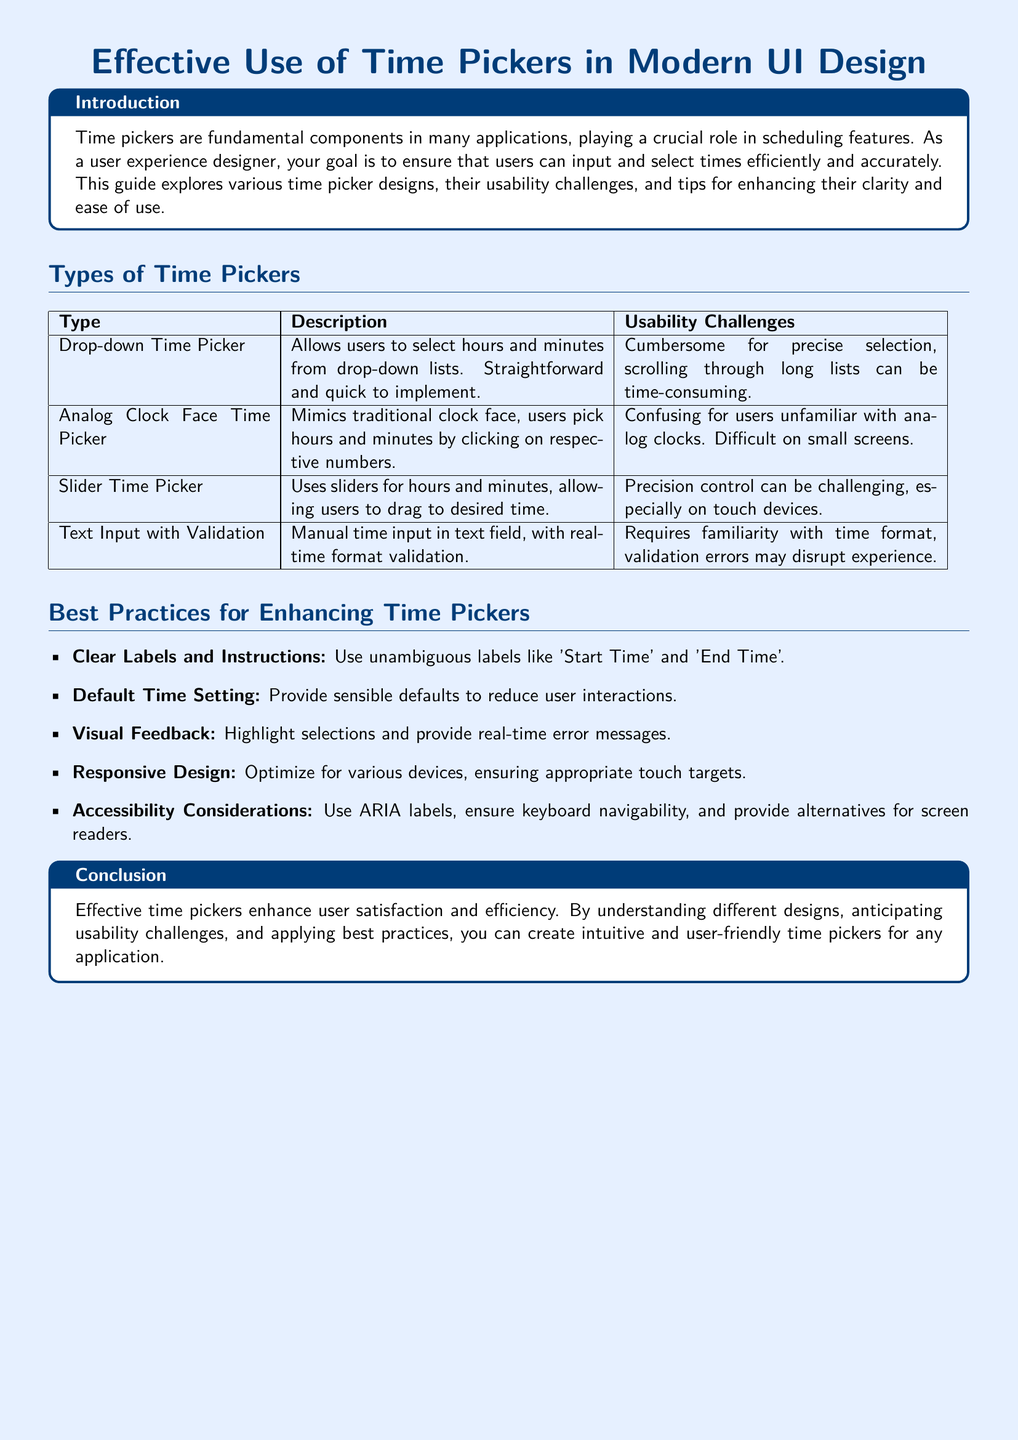What are the types of time pickers discussed? The document lists four types of time pickers: Drop-down Time Picker, Analog Clock Face Time Picker, Slider Time Picker, and Text Input with Validation.
Answer: Drop-down Time Picker, Analog Clock Face Time Picker, Slider Time Picker, Text Input with Validation What is the primary role of time pickers in applications? Time pickers are fundamental components playing a crucial role in scheduling features.
Answer: Scheduling features What usability challenge is associated with the Analog Clock Face Time Picker? The document states that it can be confusing for users unfamiliar with analog clocks and difficult on small screens.
Answer: Confusing for users Which best practice suggests providing a default time? The best practices section discusses reducing user interactions by providing sensible defaults.
Answer: Default Time Setting What type of design does the document suggest in the best practices for various devices? It emphasizes the need for optimizing time pickers for various devices.
Answer: Responsive Design How many total usability challenges are mentioned for the Drop-down Time Picker? The document states one usability challenge for the Drop-down Time Picker: cumbersome for precise selection and time-consuming scrolling.
Answer: One What should be used for screen readers according to the document? The best practices include providing alternatives for screen readers.
Answer: Alternatives for screen readers What is the conclusion about effective time pickers? The conclusion emphasizes that they enhance user satisfaction and efficiency.
Answer: Enhance user satisfaction and efficiency Which best practice requires clarity in labels and instructions? The document states the importance of using unambiguous labels for effective time pickers.
Answer: Clear Labels and Instructions 